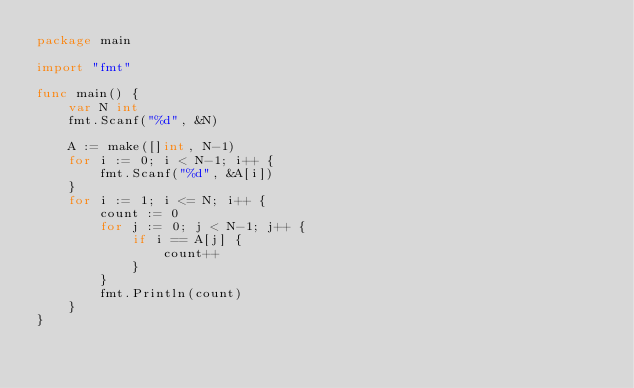Convert code to text. <code><loc_0><loc_0><loc_500><loc_500><_Go_>package main

import "fmt"

func main() {
	var N int
	fmt.Scanf("%d", &N)

	A := make([]int, N-1)
	for i := 0; i < N-1; i++ {
		fmt.Scanf("%d", &A[i])
	}
	for i := 1; i <= N; i++ {
		count := 0
		for j := 0; j < N-1; j++ {
			if i == A[j] {
				count++
			}
		}
		fmt.Println(count)
	}
}
</code> 